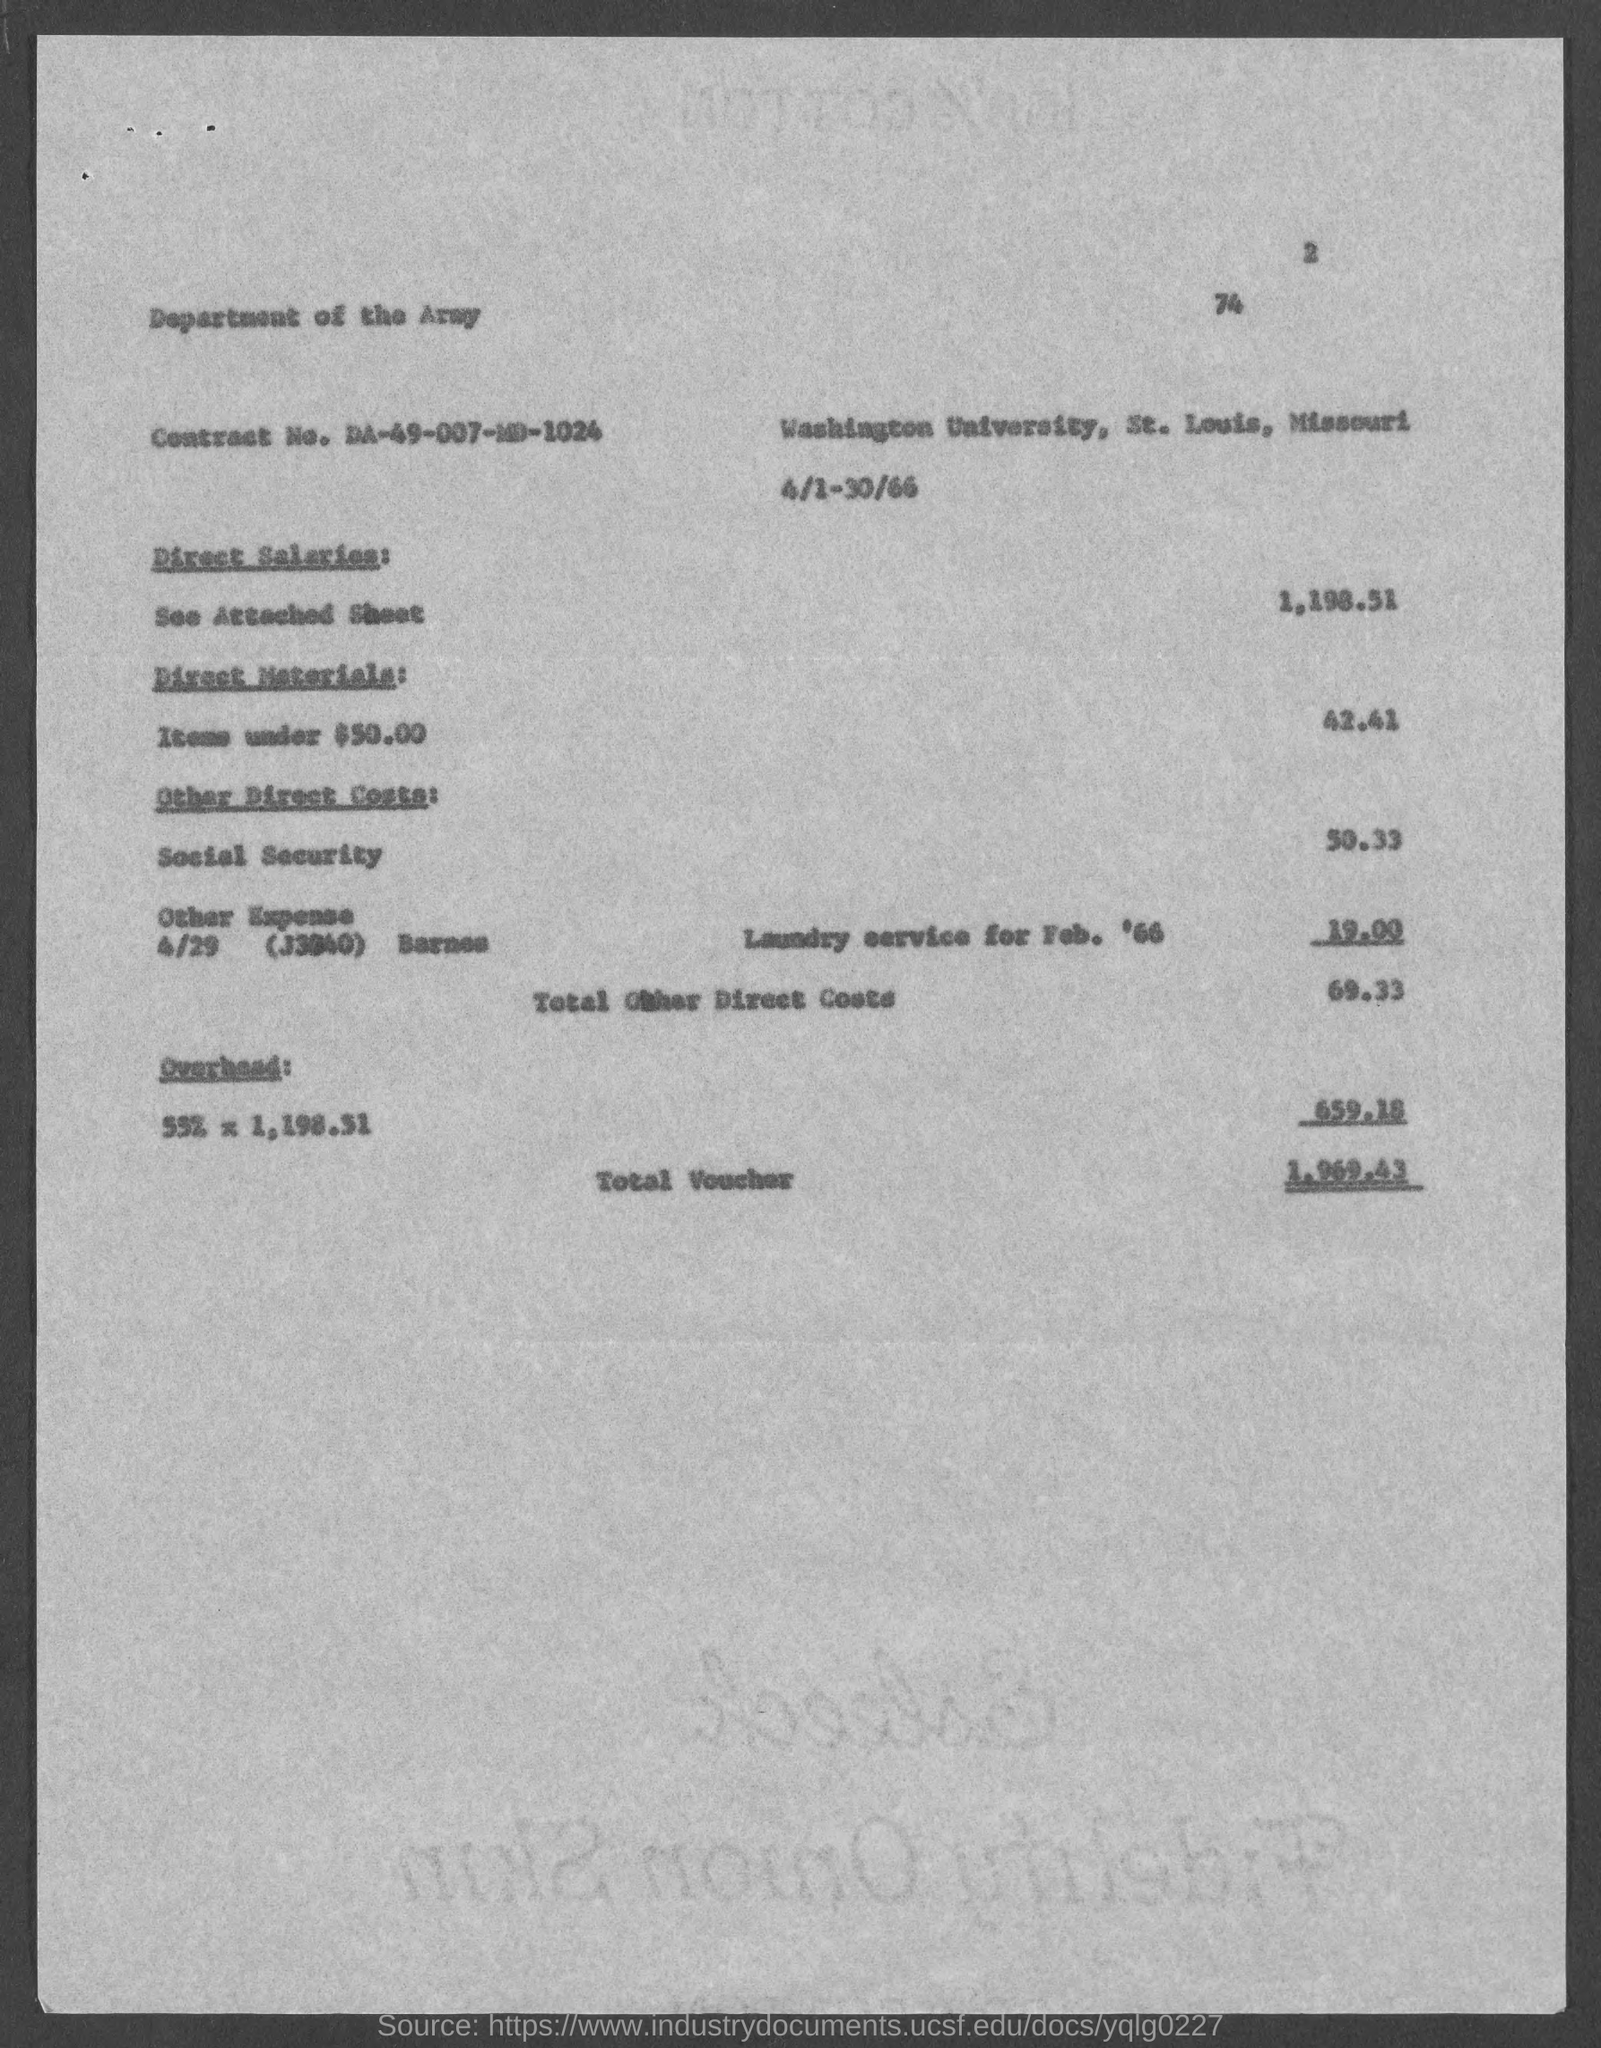Give some essential details in this illustration. The page number at the top of the page is 2. The contract number is DA-49-007-MD-1024. The total voucher amount is $1,969.43. 